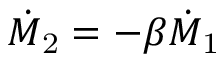<formula> <loc_0><loc_0><loc_500><loc_500>\dot { M } _ { 2 } = - \beta \dot { M } _ { 1 }</formula> 